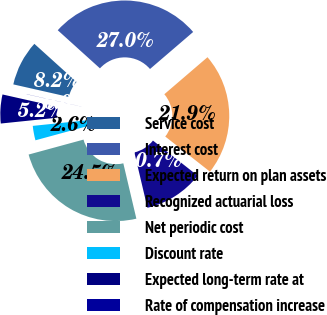Convert chart to OTSL. <chart><loc_0><loc_0><loc_500><loc_500><pie_chart><fcel>Service cost<fcel>Interest cost<fcel>Expected return on plan assets<fcel>Recognized actuarial loss<fcel>Net periodic cost<fcel>Discount rate<fcel>Expected long-term rate at<fcel>Rate of compensation increase<nl><fcel>8.15%<fcel>27.02%<fcel>21.88%<fcel>10.72%<fcel>24.45%<fcel>2.59%<fcel>5.16%<fcel>0.02%<nl></chart> 